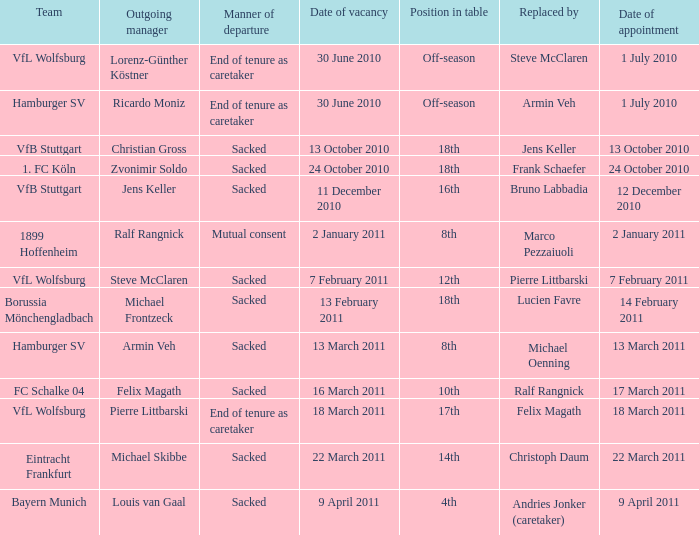When 24 October 2010. 